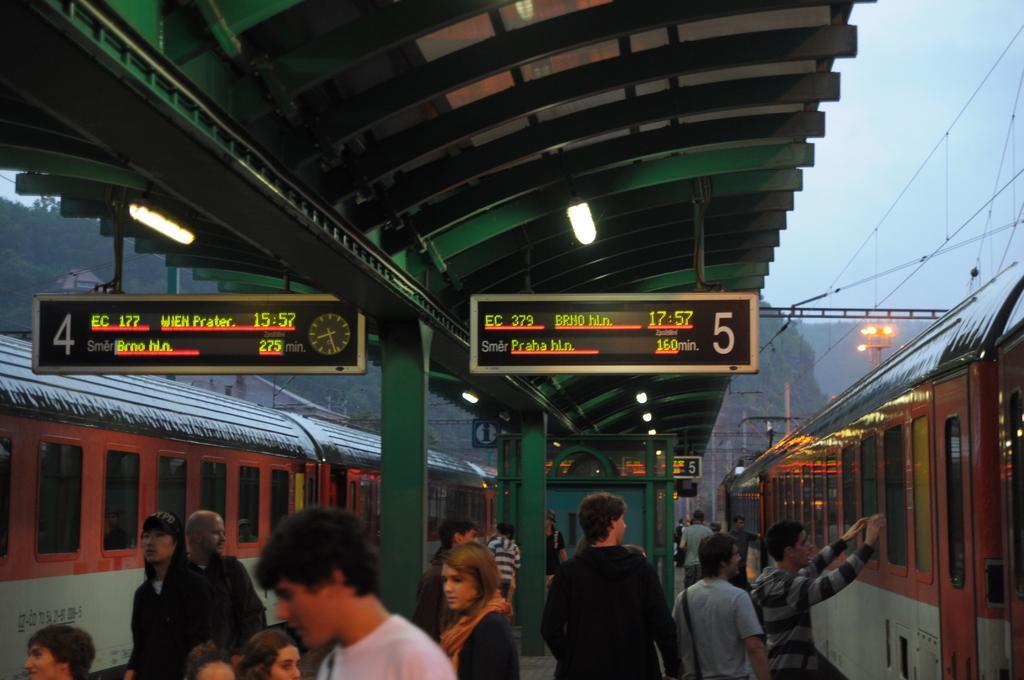Can you describe this image briefly? In this image we can see people standing on the platform. Here we can see trains, poles, boards, lights, roof, and wires. In the background we can see mountain and sky. 